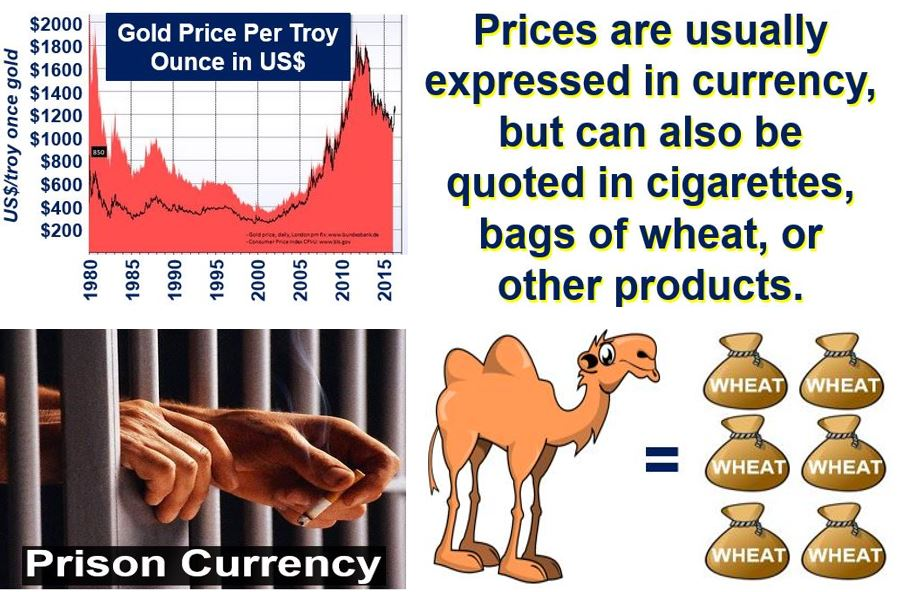If wheat were to be used as currency in the image, how might its value be determined inside a prison? If wheat were to be used as currency in a prison, its value would primarily be determined by its availability and the demand among inmates. Factors influencing its value could include its utility, nutritional need, and rarity. For instance, if wheat is a rare commodity within the prison and serves as an important food source, its value would be high. Conversely, if wheat is abundant but not highly utilized, its value might be lower. The prison's internal trading system, reflecting the immediate supply and demand, governs these valuations. 